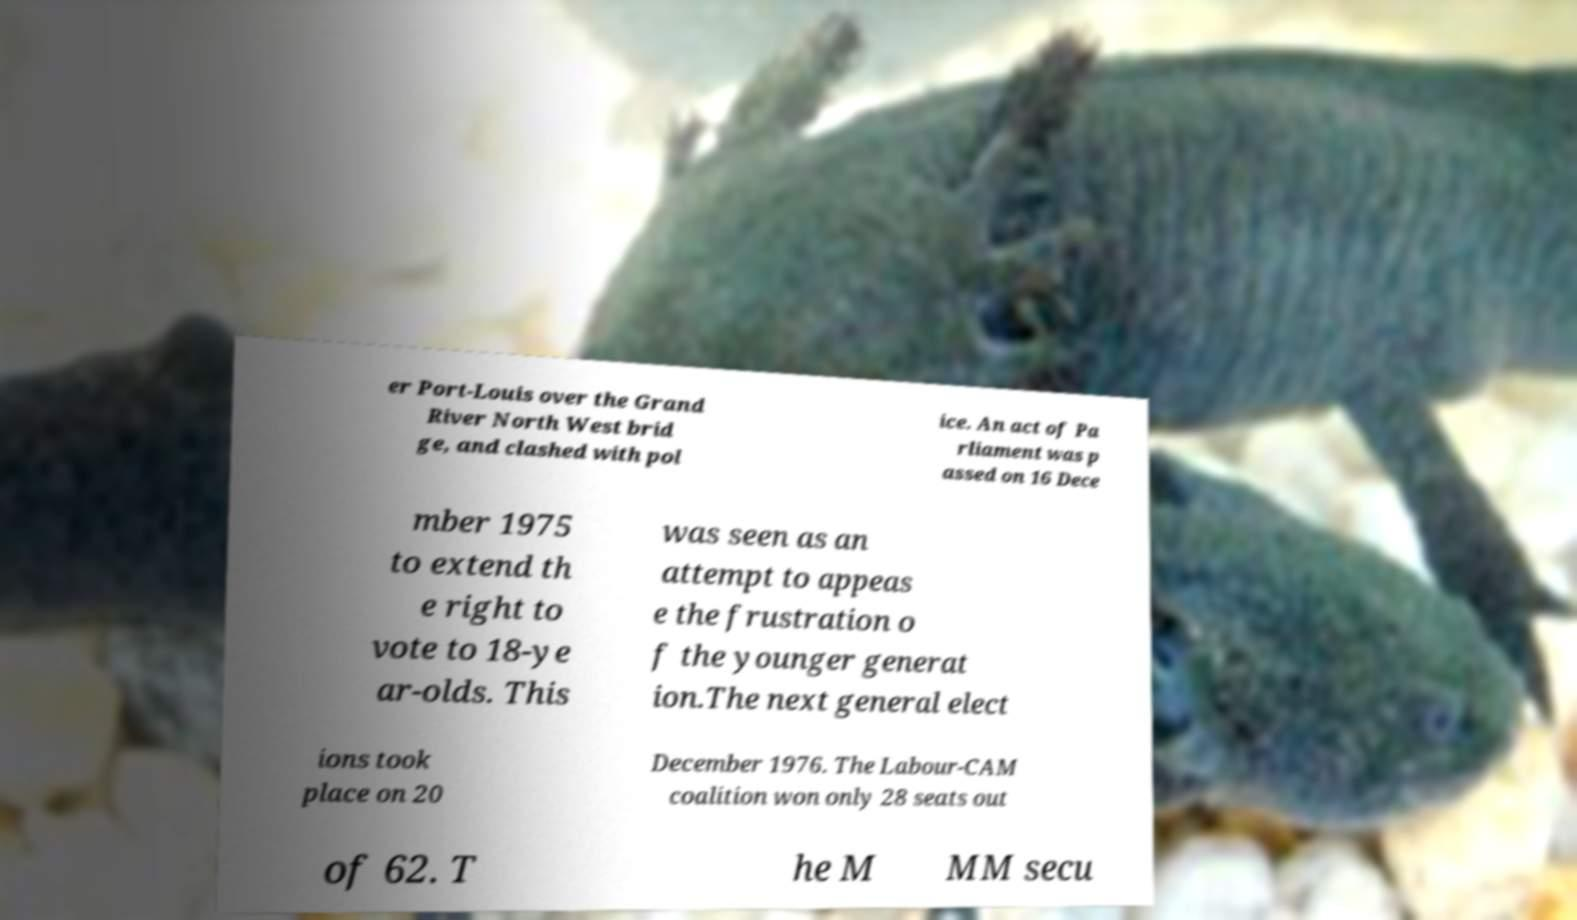Could you assist in decoding the text presented in this image and type it out clearly? er Port-Louis over the Grand River North West brid ge, and clashed with pol ice. An act of Pa rliament was p assed on 16 Dece mber 1975 to extend th e right to vote to 18-ye ar-olds. This was seen as an attempt to appeas e the frustration o f the younger generat ion.The next general elect ions took place on 20 December 1976. The Labour-CAM coalition won only 28 seats out of 62. T he M MM secu 